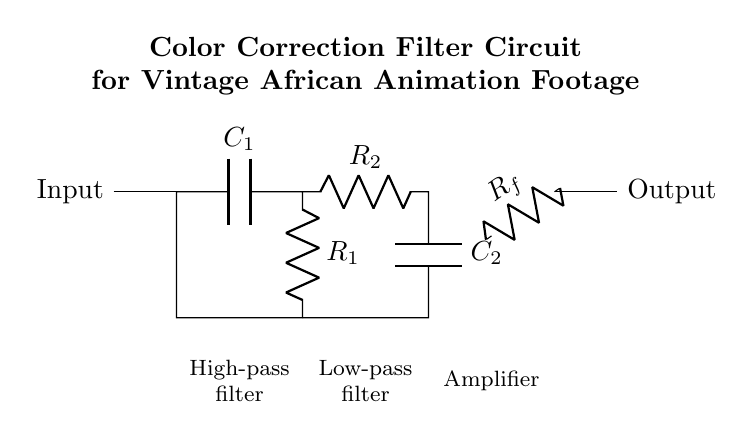What type of components are present in this circuit? The circuit includes capacitors (C1, C2), resistors (R1, R2, Rf), and an operational amplifier. These components are commonly used in filter circuits for signal processing.
Answer: capacitors, resistors, operational amplifier What is the function of the high-pass filter in this circuit? The high-pass filter, consisting of C1 and R1, allows frequencies above a certain cutoff frequency to pass while attenuating lower frequencies. This is important for removing low-frequency noise from the vintage animation footage.
Answer: allows high frequencies to pass What signal does the amplifier process in this circuit? The amplifier receives the filtered signal from the low-pass filter, amplifying it to enhance the output signal strength after filtering. Amplification is especially significant in restoring footage.
Answer: filtered signal How many resistors are in this circuit? The circuit has three resistors: R1, R2, and Rf. Each plays a role in determining the behavior of the filters and the amplifier.
Answer: three What is the role of the capacitor C2 in the low-pass filter? Capacitor C2 in the low-pass filter works with R2 to allow signals below a specified frequency to pass while attenuating higher frequencies, helping to restore the original quality of the footage without high-frequency artifacts.
Answer: attenuates high frequencies What happens to the output signal after passing through the circuit? After the output signal passes through the high-pass and low-pass filters and gets amplified by the operational amplifier, it is outputted, resulting in a cleaner and enhanced version of the original footage. This is crucial for preserving the intended aesthetics of the vintage animation.
Answer: cleaner, enhanced output signal 